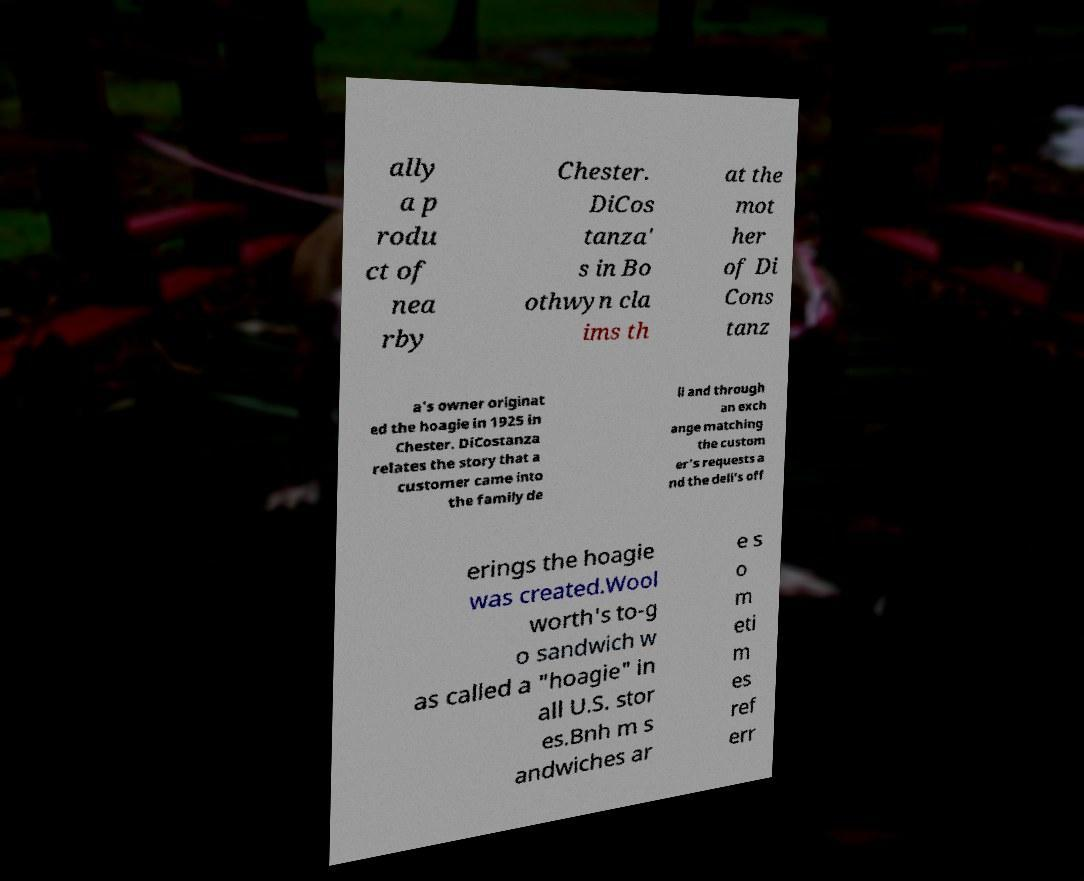There's text embedded in this image that I need extracted. Can you transcribe it verbatim? ally a p rodu ct of nea rby Chester. DiCos tanza' s in Bo othwyn cla ims th at the mot her of Di Cons tanz a's owner originat ed the hoagie in 1925 in Chester. DiCostanza relates the story that a customer came into the family de li and through an exch ange matching the custom er's requests a nd the deli's off erings the hoagie was created.Wool worth's to-g o sandwich w as called a "hoagie" in all U.S. stor es.Bnh m s andwiches ar e s o m eti m es ref err 